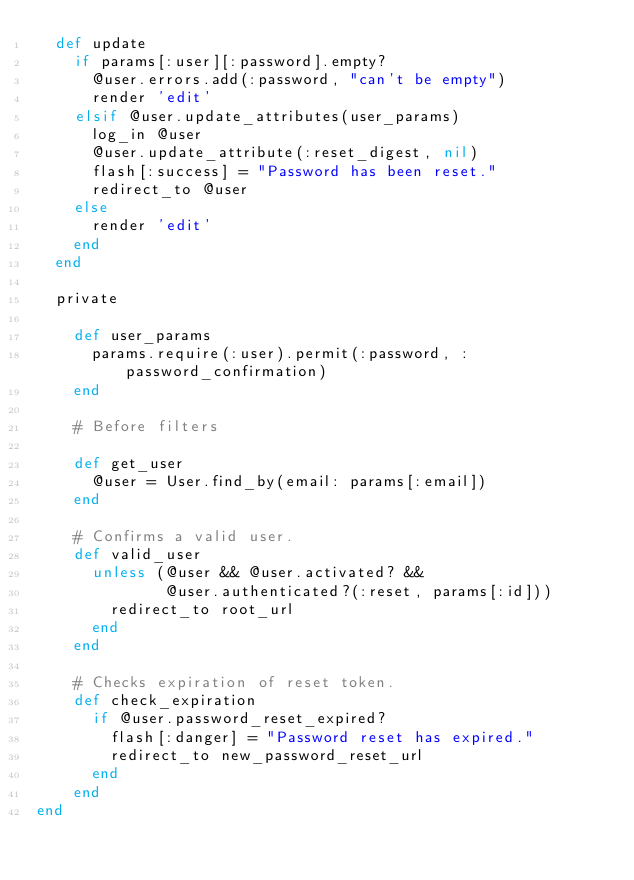Convert code to text. <code><loc_0><loc_0><loc_500><loc_500><_Ruby_>  def update
    if params[:user][:password].empty?
      @user.errors.add(:password, "can't be empty")
      render 'edit'
    elsif @user.update_attributes(user_params)
      log_in @user
      @user.update_attribute(:reset_digest, nil)
      flash[:success] = "Password has been reset."
      redirect_to @user
    else
      render 'edit'
    end
  end
  
  private

    def user_params
      params.require(:user).permit(:password, :password_confirmation)
    end

    # Before filters

    def get_user
      @user = User.find_by(email: params[:email])
    end

    # Confirms a valid user.
    def valid_user
      unless (@user && @user.activated? &&
              @user.authenticated?(:reset, params[:id]))
        redirect_to root_url
      end
    end

    # Checks expiration of reset token.
    def check_expiration
      if @user.password_reset_expired?
        flash[:danger] = "Password reset has expired."
        redirect_to new_password_reset_url
      end
    end
end</code> 